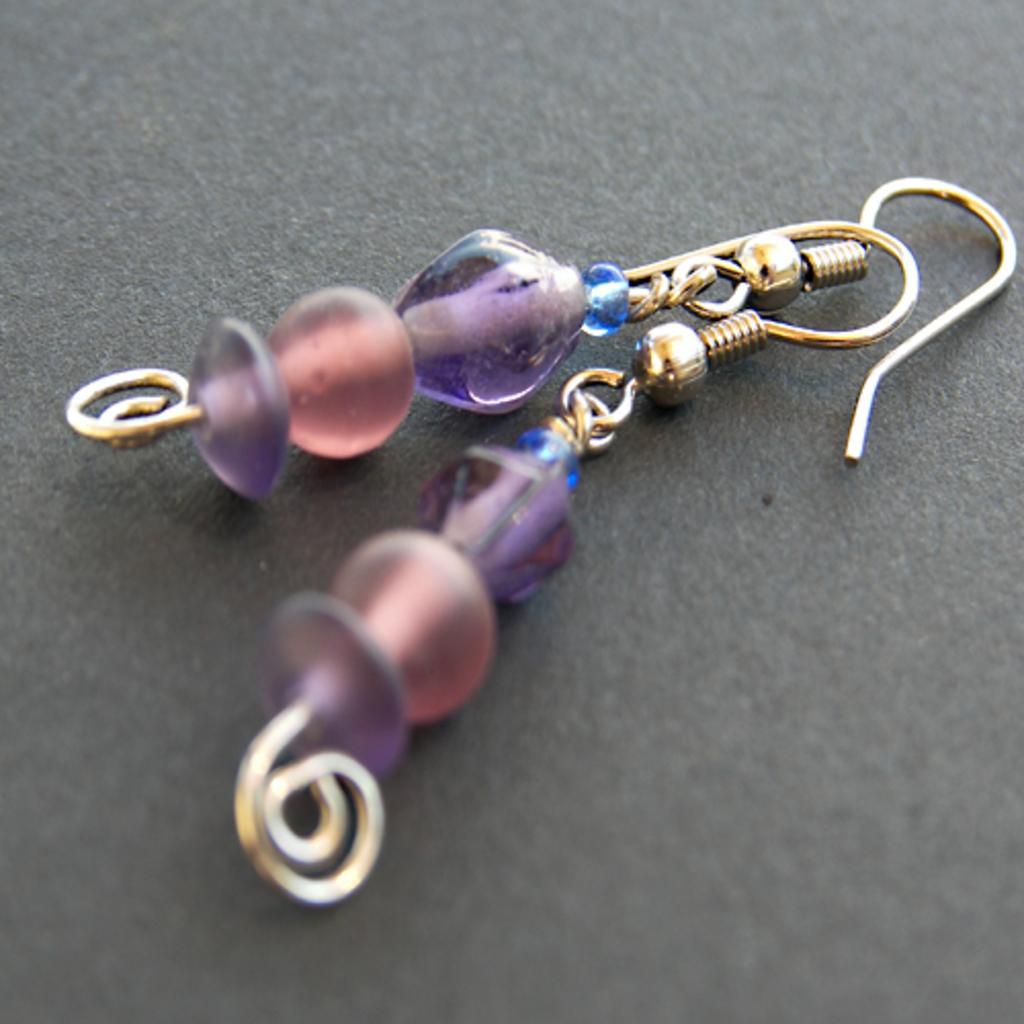Describe this image in one or two sentences. This picture contains two long bead earrings. In the background, it is black in color. 